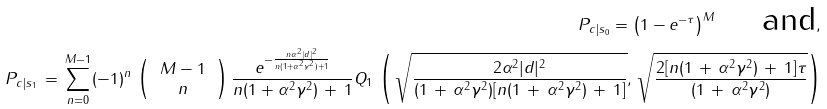Convert formula to latex. <formula><loc_0><loc_0><loc_500><loc_500>P _ { c | s _ { 0 } } = \left ( 1 - e ^ { - \tau } \right ) ^ { M } \quad \text { and} , \\ \, P _ { c | s _ { 1 } } \, = \, \sum _ { n = 0 } ^ { M - 1 } ( - 1 ) ^ { n } \, \left ( \, \begin{array} { c c } M - 1 \\ n \end{array} \, \right ) \frac { e ^ { - \frac { n \alpha ^ { 2 } | d | ^ { 2 } } { n ( 1 + \alpha ^ { 2 } \gamma ^ { 2 } ) + 1 } } } { n ( 1 + \alpha ^ { 2 } \gamma ^ { 2 } ) \, + \, 1 } Q _ { 1 } \, \left ( \, \sqrt { \frac { 2 \alpha ^ { 2 } | d | ^ { 2 } } { ( 1 \, + \, \alpha ^ { 2 } \gamma ^ { 2 } ) [ n ( 1 \, + \, \alpha ^ { 2 } \gamma ^ { 2 } ) \, + \, 1 ] } } , \, \sqrt { \frac { 2 [ n ( 1 \, + \, \alpha ^ { 2 } \gamma ^ { 2 } ) \, + \, 1 ] \tau } { ( 1 \, + \, \alpha ^ { 2 } \gamma ^ { 2 } ) } } \right )</formula> 